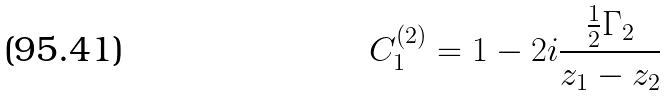Convert formula to latex. <formula><loc_0><loc_0><loc_500><loc_500>C _ { 1 } ^ { ( 2 ) } = 1 - 2 i { \frac { { \frac { 1 } { 2 } } \Gamma _ { 2 } } { z _ { 1 } - z _ { 2 } } }</formula> 